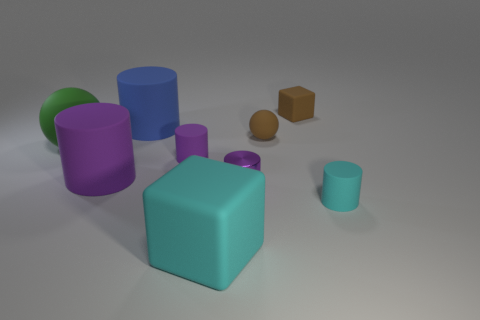Is the number of big cyan rubber blocks on the right side of the small block less than the number of large purple matte things?
Keep it short and to the point. Yes. What shape is the other cyan thing that is the same size as the metal object?
Offer a very short reply. Cylinder. How many other objects are the same color as the big rubber ball?
Your answer should be very brief. 0. Does the shiny object have the same size as the green matte ball?
Give a very brief answer. No. What number of things are tiny objects or objects that are in front of the small cyan thing?
Your answer should be very brief. 6. Are there fewer blue matte objects that are right of the large rubber block than green matte balls that are on the right side of the small brown ball?
Provide a succinct answer. No. What number of other objects are there of the same material as the large ball?
Keep it short and to the point. 7. Do the large rubber object behind the small ball and the large rubber sphere have the same color?
Give a very brief answer. No. Are there any green objects that are on the left side of the small cylinder that is behind the small metallic thing?
Your answer should be very brief. Yes. There is a object that is both on the right side of the brown ball and on the left side of the small cyan rubber cylinder; what material is it?
Make the answer very short. Rubber. 